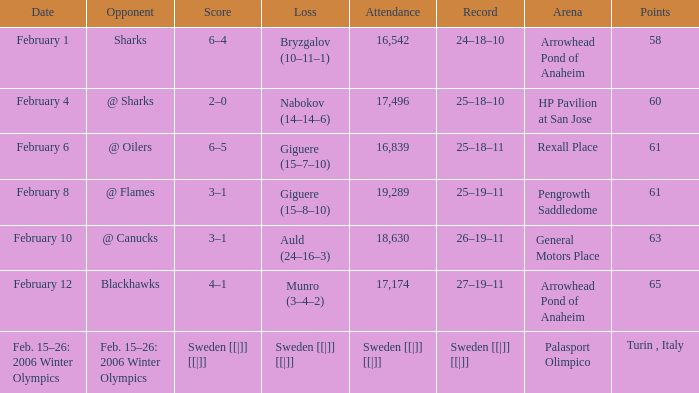What is the record at Arrowhead Pond of Anaheim, when the loss was Bryzgalov (10–11–1)? 24–18–10. 